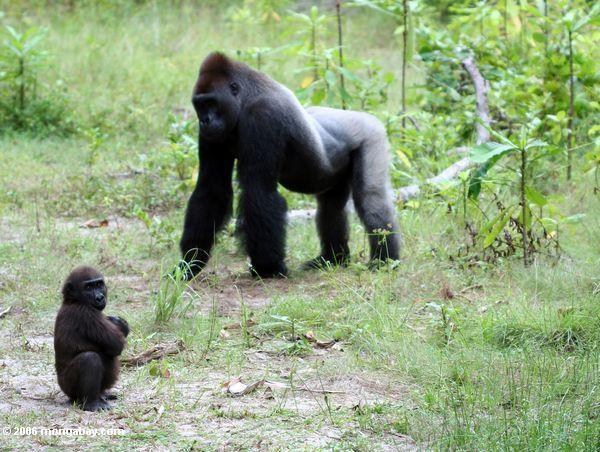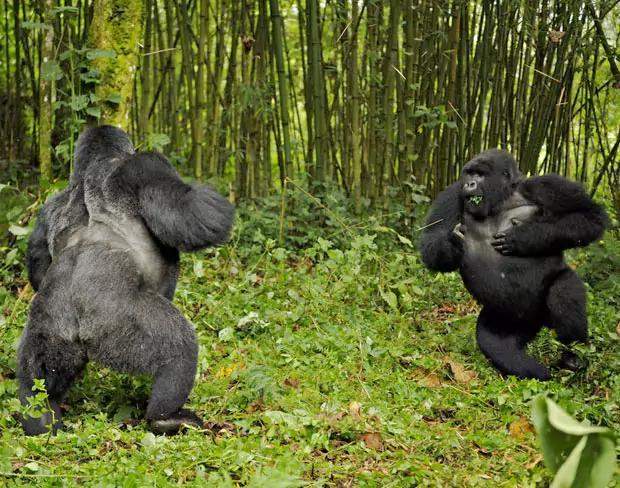The first image is the image on the left, the second image is the image on the right. For the images shown, is this caption "In one of the images there is a baby gorilla near at least one adult gorilla." true? Answer yes or no. Yes. The first image is the image on the left, the second image is the image on the right. For the images displayed, is the sentence "There are no more than three gorillas" factually correct? Answer yes or no. No. The first image is the image on the left, the second image is the image on the right. Analyze the images presented: Is the assertion "At least one images contains a very young gorilla." valid? Answer yes or no. Yes. 